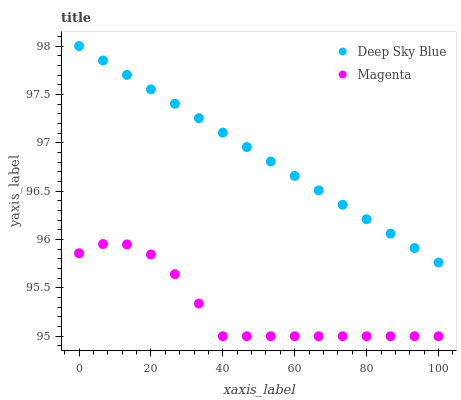Does Magenta have the minimum area under the curve?
Answer yes or no. Yes. Does Deep Sky Blue have the maximum area under the curve?
Answer yes or no. Yes. Does Deep Sky Blue have the minimum area under the curve?
Answer yes or no. No. Is Deep Sky Blue the smoothest?
Answer yes or no. Yes. Is Magenta the roughest?
Answer yes or no. Yes. Is Deep Sky Blue the roughest?
Answer yes or no. No. Does Magenta have the lowest value?
Answer yes or no. Yes. Does Deep Sky Blue have the lowest value?
Answer yes or no. No. Does Deep Sky Blue have the highest value?
Answer yes or no. Yes. Is Magenta less than Deep Sky Blue?
Answer yes or no. Yes. Is Deep Sky Blue greater than Magenta?
Answer yes or no. Yes. Does Magenta intersect Deep Sky Blue?
Answer yes or no. No. 